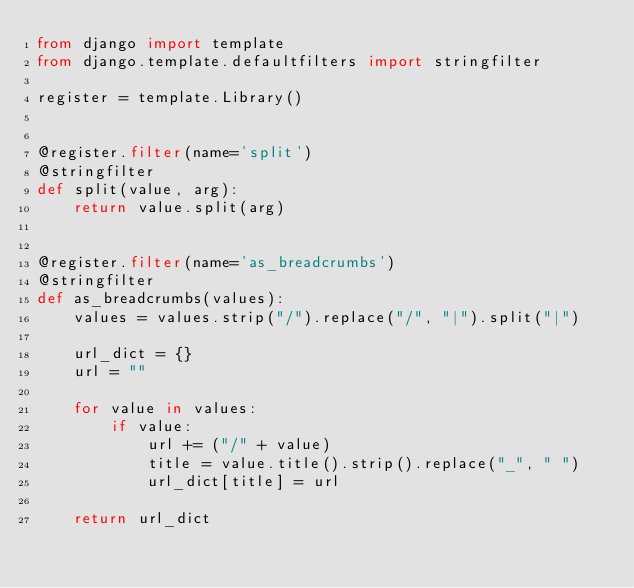Convert code to text. <code><loc_0><loc_0><loc_500><loc_500><_Python_>from django import template
from django.template.defaultfilters import stringfilter

register = template.Library()


@register.filter(name='split')
@stringfilter
def split(value, arg):
    return value.split(arg)


@register.filter(name='as_breadcrumbs')
@stringfilter
def as_breadcrumbs(values):
    values = values.strip("/").replace("/", "|").split("|")

    url_dict = {}
    url = ""

    for value in values:
        if value:
            url += ("/" + value)
            title = value.title().strip().replace("_", " ")
            url_dict[title] = url

    return url_dict
</code> 